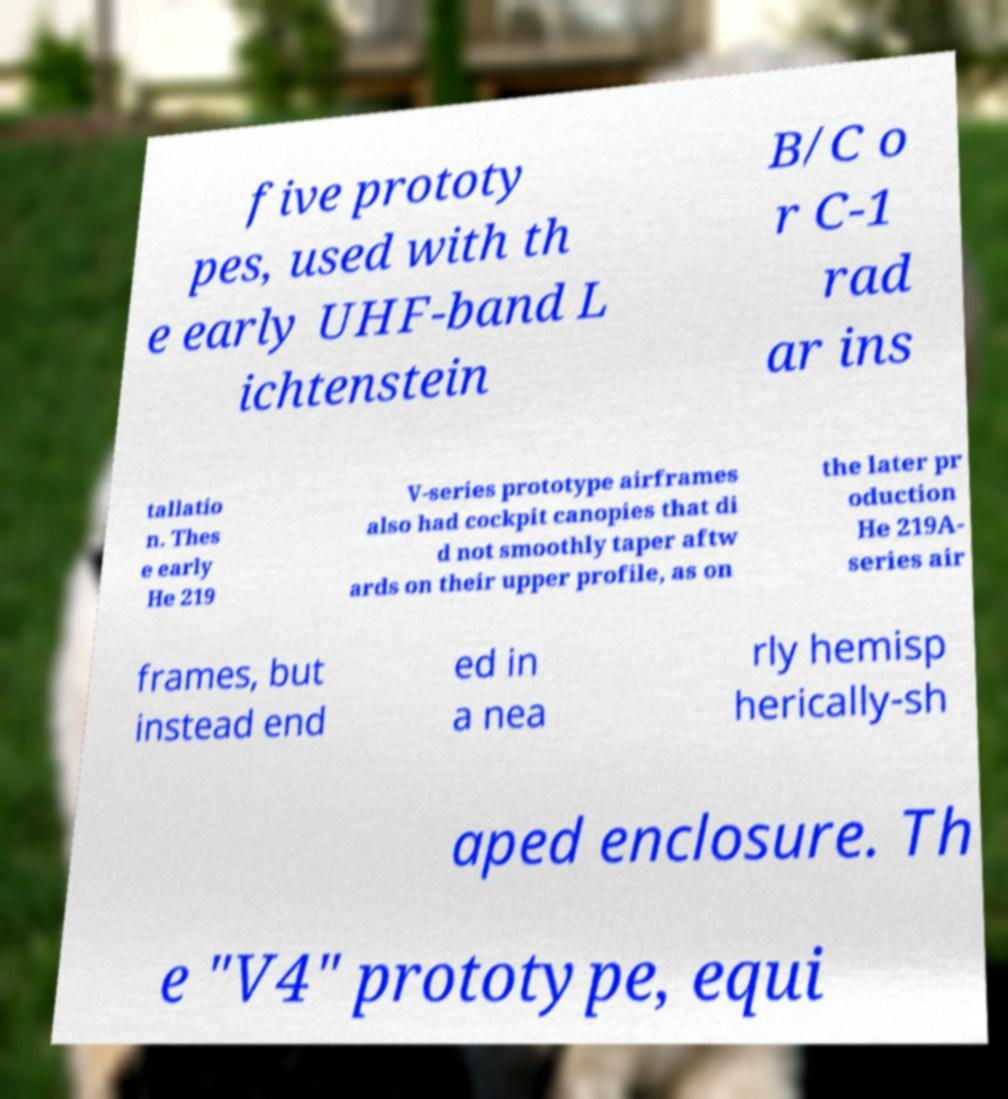For documentation purposes, I need the text within this image transcribed. Could you provide that? five prototy pes, used with th e early UHF-band L ichtenstein B/C o r C-1 rad ar ins tallatio n. Thes e early He 219 V-series prototype airframes also had cockpit canopies that di d not smoothly taper aftw ards on their upper profile, as on the later pr oduction He 219A- series air frames, but instead end ed in a nea rly hemisp herically-sh aped enclosure. Th e "V4" prototype, equi 